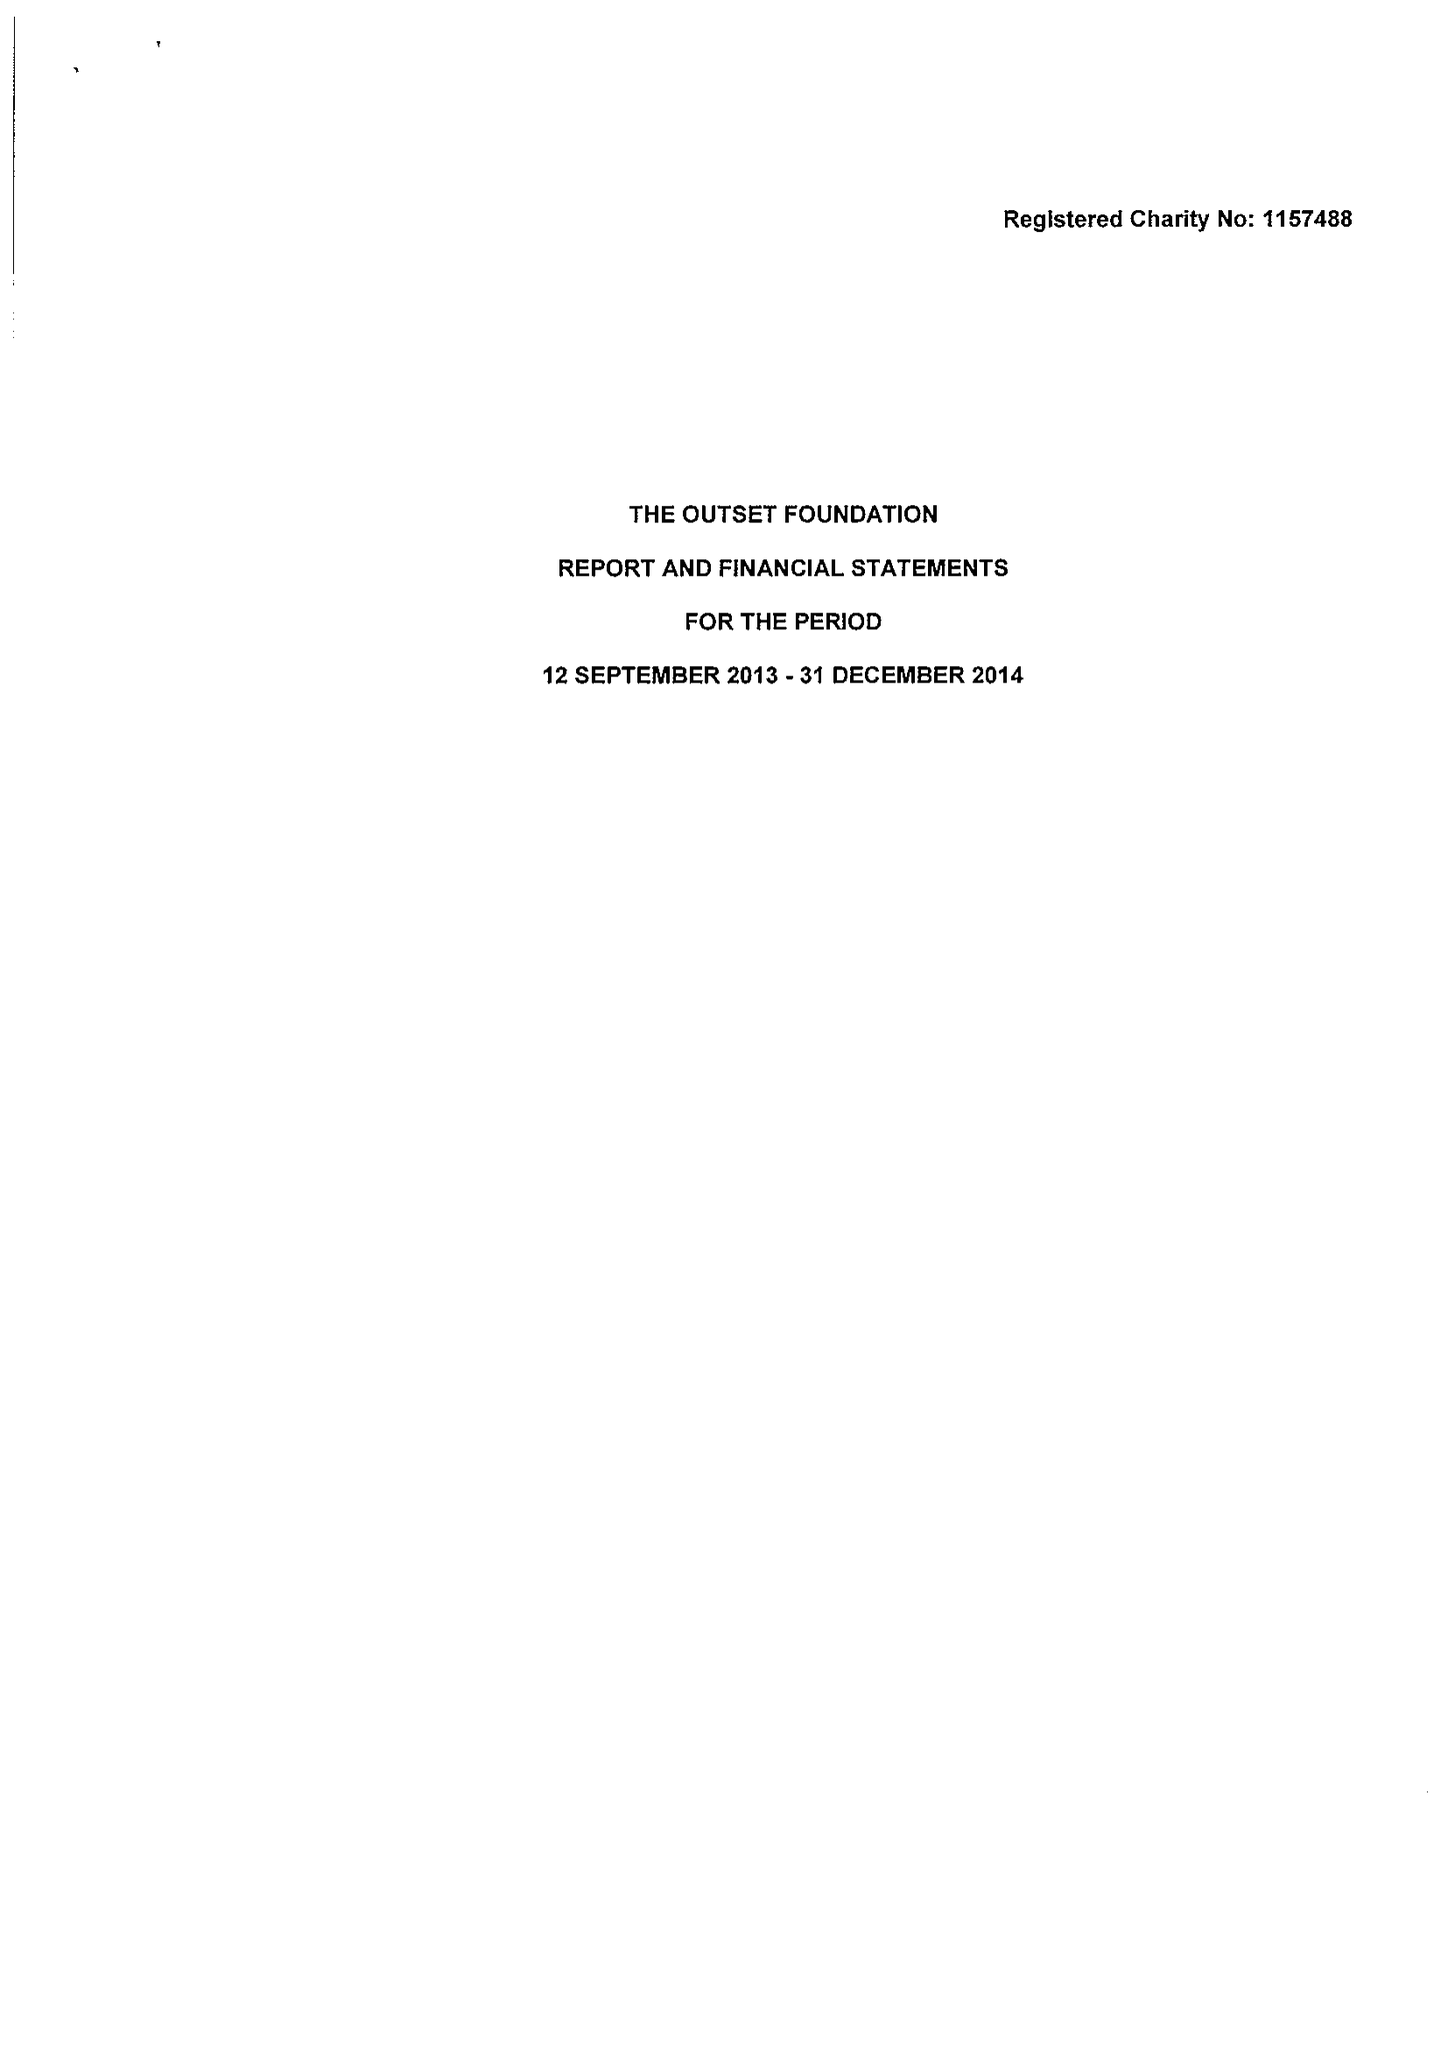What is the value for the spending_annually_in_british_pounds?
Answer the question using a single word or phrase. 516.00 